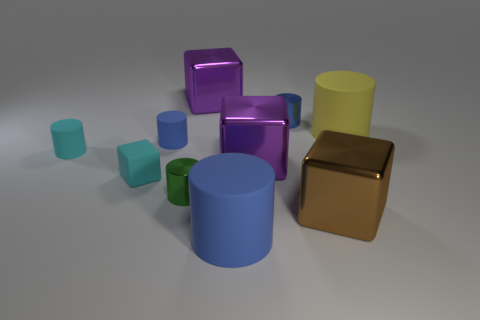Subtract all tiny green metallic cylinders. How many cylinders are left? 5 Subtract 1 blocks. How many blocks are left? 3 Subtract all yellow cylinders. How many cylinders are left? 5 Subtract all tiny objects. Subtract all big gray matte objects. How many objects are left? 5 Add 7 tiny cyan things. How many tiny cyan things are left? 9 Add 3 small blue objects. How many small blue objects exist? 5 Subtract 0 yellow blocks. How many objects are left? 10 Subtract all cylinders. How many objects are left? 4 Subtract all red cylinders. Subtract all gray balls. How many cylinders are left? 6 Subtract all yellow cylinders. How many cyan blocks are left? 1 